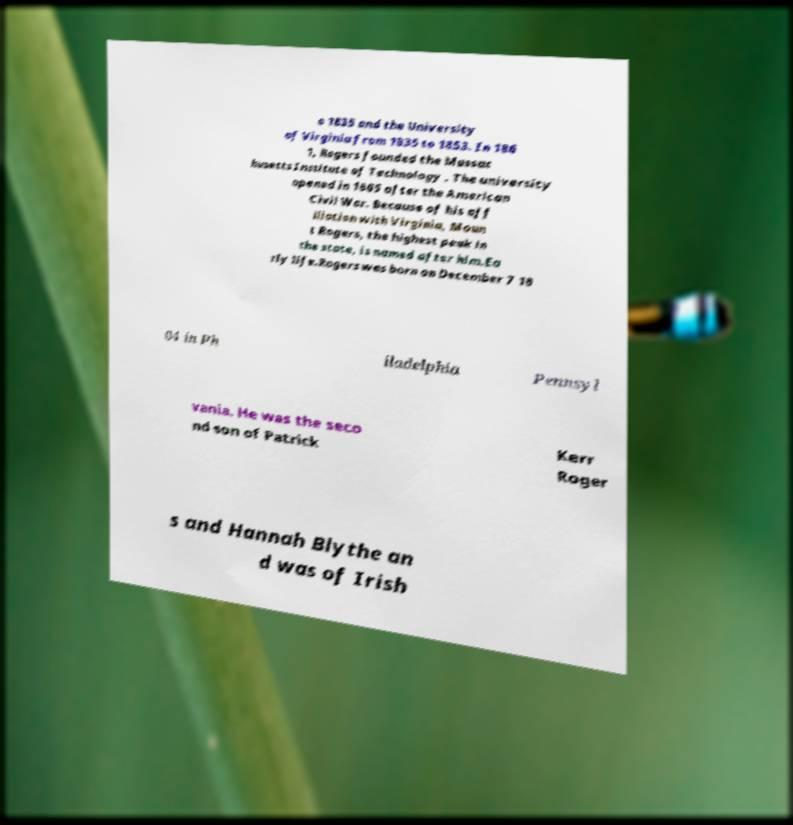Could you extract and type out the text from this image? o 1835 and the University of Virginia from 1835 to 1853. In 186 1, Rogers founded the Massac husetts Institute of Technology . The university opened in 1865 after the American Civil War. Because of his aff iliation with Virginia, Moun t Rogers, the highest peak in the state, is named after him.Ea rly life.Rogers was born on December 7 18 04 in Ph iladelphia Pennsyl vania. He was the seco nd son of Patrick Kerr Roger s and Hannah Blythe an d was of Irish 